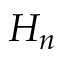Convert formula to latex. <formula><loc_0><loc_0><loc_500><loc_500>H _ { n }</formula> 